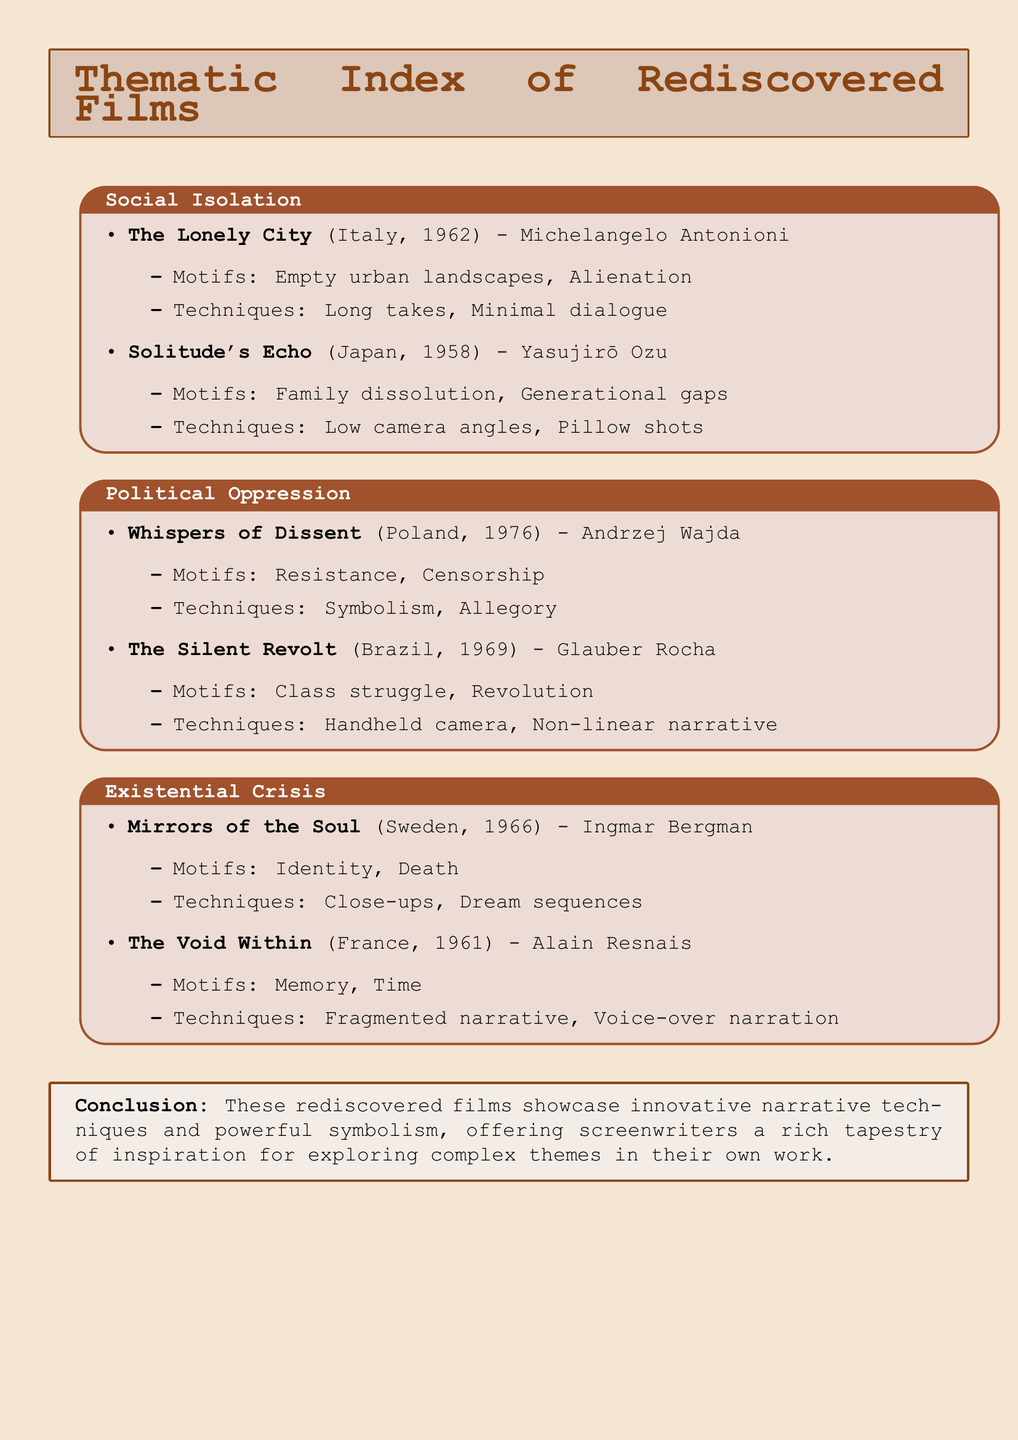What is the title of the Italian film about social isolation? The document lists "The Lonely City" as the Italian film concerning social isolation, directed by Michelangelo Antonioni.
Answer: The Lonely City Who directed "Solitude's Echo"? The film "Solitude's Echo" was directed by Yasujirō Ozu, as mentioned in the document.
Answer: Yasujirō Ozu What motif is associated with "Whispers of Dissent"? The document states that the motif associated with "Whispers of Dissent" is resistance, highlighting its focus on political themes.
Answer: Resistance Which narrative technique is employed in "The Void Within"? According to the document, "The Void Within" utilizes a fragmented narrative as a key storytelling technique.
Answer: Fragmented narrative How many films are listed under the theme of political oppression? The document includes two films under the theme of political oppression, providing examples and associated details.
Answer: Two What year was "Mirrors of the Soul" released? The document specifies that "Mirrors of the Soul" was released in 1966, placing it in a particular period of cinematic history.
Answer: 1966 Which country produced "The Silent Revolt"? The document identifies Brazil as the country of origin for "The Silent Revolt."
Answer: Brazil What common theme is shared by "The Lonely City" and "Solitude's Echo"? Both films explore the theme of social isolation, as grouped in the document.
Answer: Social isolation 